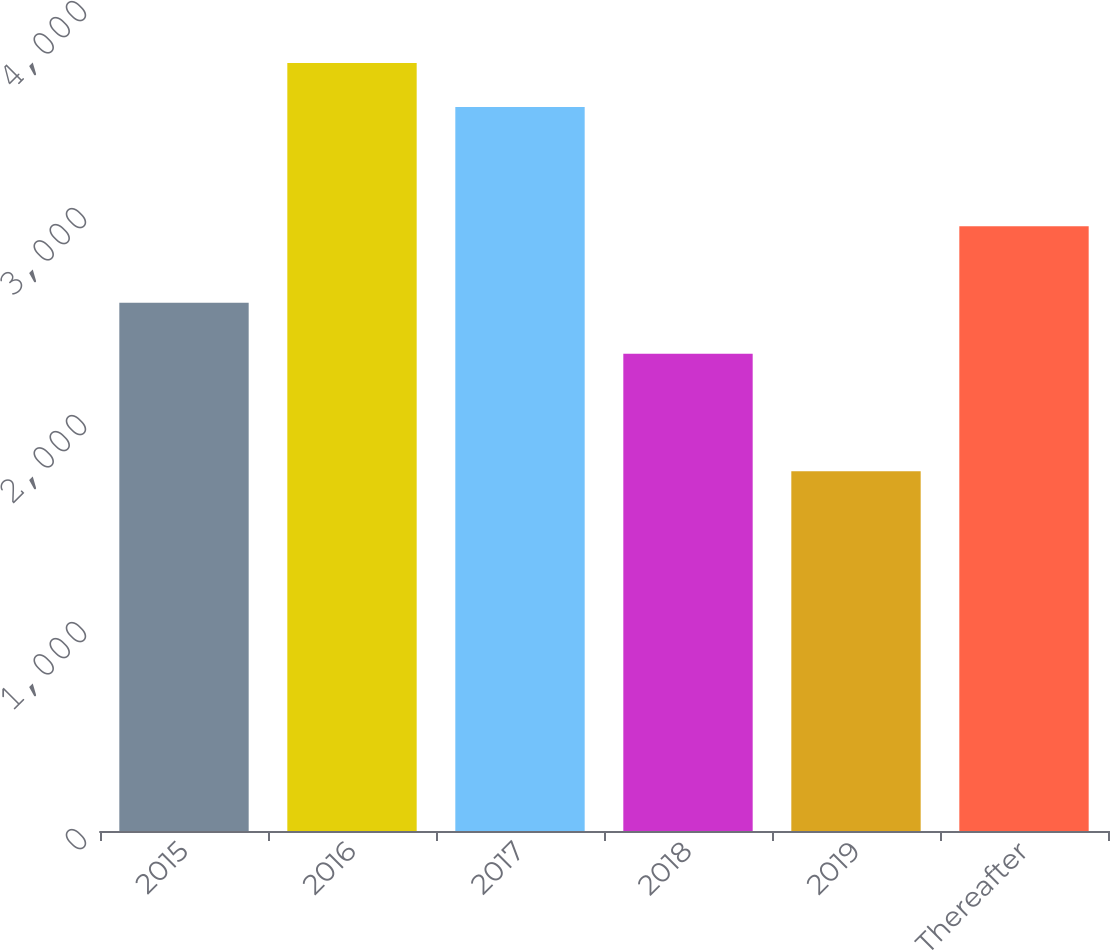<chart> <loc_0><loc_0><loc_500><loc_500><bar_chart><fcel>2015<fcel>2016<fcel>2017<fcel>2018<fcel>2019<fcel>Thereafter<nl><fcel>2552<fcel>3710<fcel>3497<fcel>2305<fcel>1738<fcel>2921<nl></chart> 